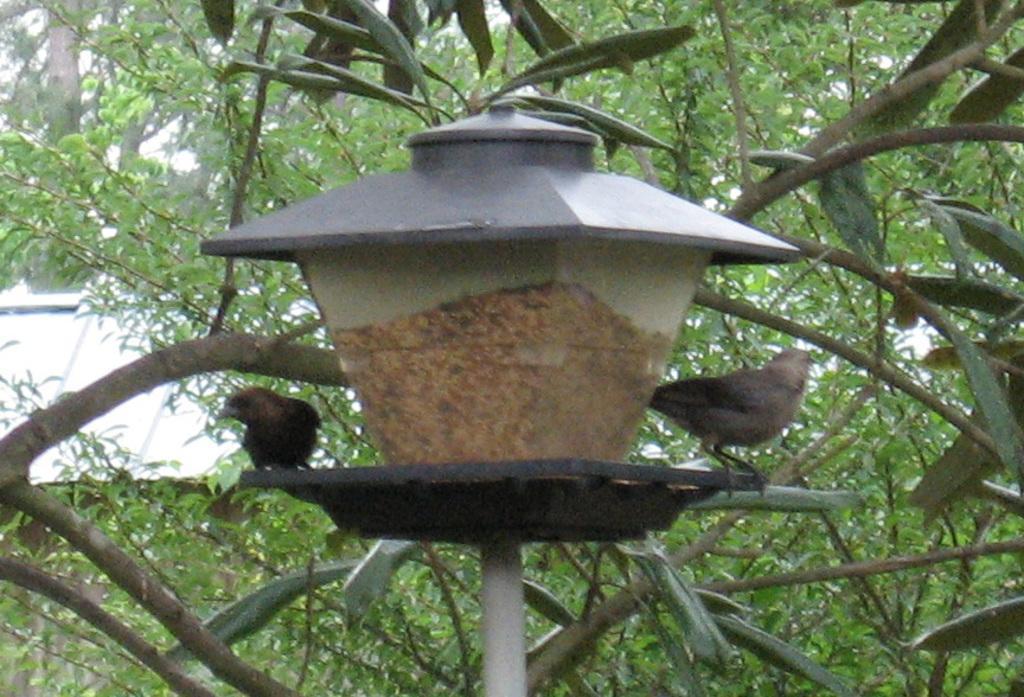Could you give a brief overview of what you see in this image? In this image I can see a light pole. There are two birds on it. In the background there are many leaves. On the left side, I can see the roof of a house. 